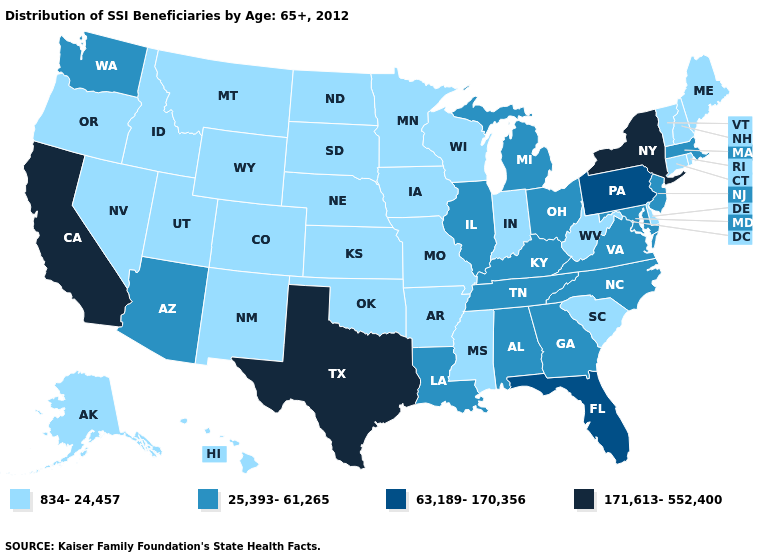What is the highest value in the USA?
Be succinct. 171,613-552,400. What is the lowest value in the USA?
Keep it brief. 834-24,457. Which states have the lowest value in the USA?
Write a very short answer. Alaska, Arkansas, Colorado, Connecticut, Delaware, Hawaii, Idaho, Indiana, Iowa, Kansas, Maine, Minnesota, Mississippi, Missouri, Montana, Nebraska, Nevada, New Hampshire, New Mexico, North Dakota, Oklahoma, Oregon, Rhode Island, South Carolina, South Dakota, Utah, Vermont, West Virginia, Wisconsin, Wyoming. What is the value of Tennessee?
Short answer required. 25,393-61,265. Among the states that border Iowa , does Illinois have the highest value?
Answer briefly. Yes. What is the value of Vermont?
Short answer required. 834-24,457. Among the states that border Louisiana , does Arkansas have the highest value?
Keep it brief. No. Does California have the highest value in the USA?
Quick response, please. Yes. Among the states that border New York , which have the lowest value?
Be succinct. Connecticut, Vermont. What is the lowest value in the USA?
Concise answer only. 834-24,457. Among the states that border Nevada , does Oregon have the highest value?
Concise answer only. No. Which states have the lowest value in the USA?
Quick response, please. Alaska, Arkansas, Colorado, Connecticut, Delaware, Hawaii, Idaho, Indiana, Iowa, Kansas, Maine, Minnesota, Mississippi, Missouri, Montana, Nebraska, Nevada, New Hampshire, New Mexico, North Dakota, Oklahoma, Oregon, Rhode Island, South Carolina, South Dakota, Utah, Vermont, West Virginia, Wisconsin, Wyoming. Among the states that border Texas , which have the lowest value?
Short answer required. Arkansas, New Mexico, Oklahoma. What is the value of Rhode Island?
Quick response, please. 834-24,457. Which states have the highest value in the USA?
Short answer required. California, New York, Texas. 